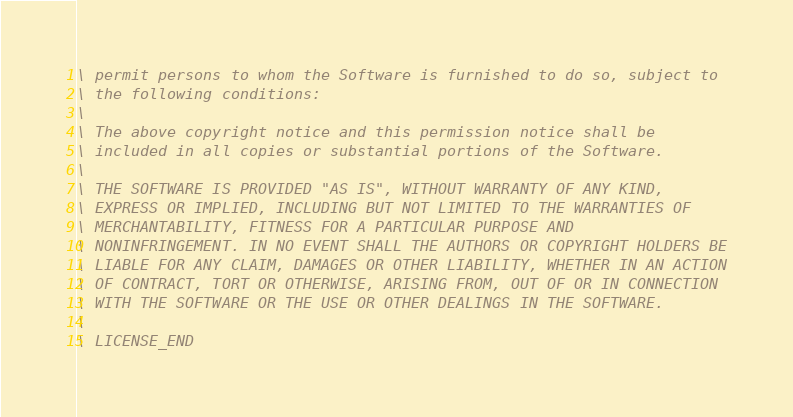Convert code to text. <code><loc_0><loc_0><loc_500><loc_500><_Forth_>\ permit persons to whom the Software is furnished to do so, subject to
\ the following conditions:
\ 
\ The above copyright notice and this permission notice shall be
\ included in all copies or substantial portions of the Software.
\ 
\ THE SOFTWARE IS PROVIDED "AS IS", WITHOUT WARRANTY OF ANY KIND,
\ EXPRESS OR IMPLIED, INCLUDING BUT NOT LIMITED TO THE WARRANTIES OF
\ MERCHANTABILITY, FITNESS FOR A PARTICULAR PURPOSE AND
\ NONINFRINGEMENT. IN NO EVENT SHALL THE AUTHORS OR COPYRIGHT HOLDERS BE
\ LIABLE FOR ANY CLAIM, DAMAGES OR OTHER LIABILITY, WHETHER IN AN ACTION
\ OF CONTRACT, TORT OR OTHERWISE, ARISING FROM, OUT OF OR IN CONNECTION
\ WITH THE SOFTWARE OR THE USE OR OTHER DEALINGS IN THE SOFTWARE.
\
\ LICENSE_END
</code> 